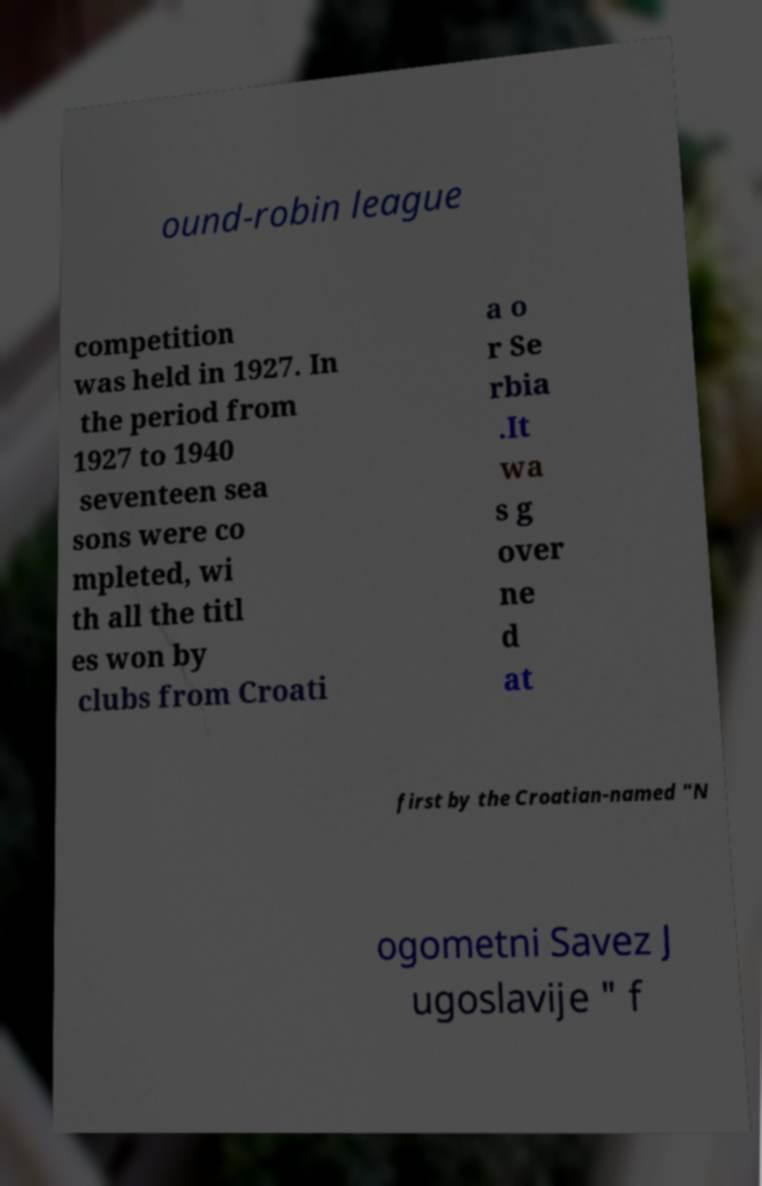Could you extract and type out the text from this image? ound-robin league competition was held in 1927. In the period from 1927 to 1940 seventeen sea sons were co mpleted, wi th all the titl es won by clubs from Croati a o r Se rbia .It wa s g over ne d at first by the Croatian-named "N ogometni Savez J ugoslavije " f 